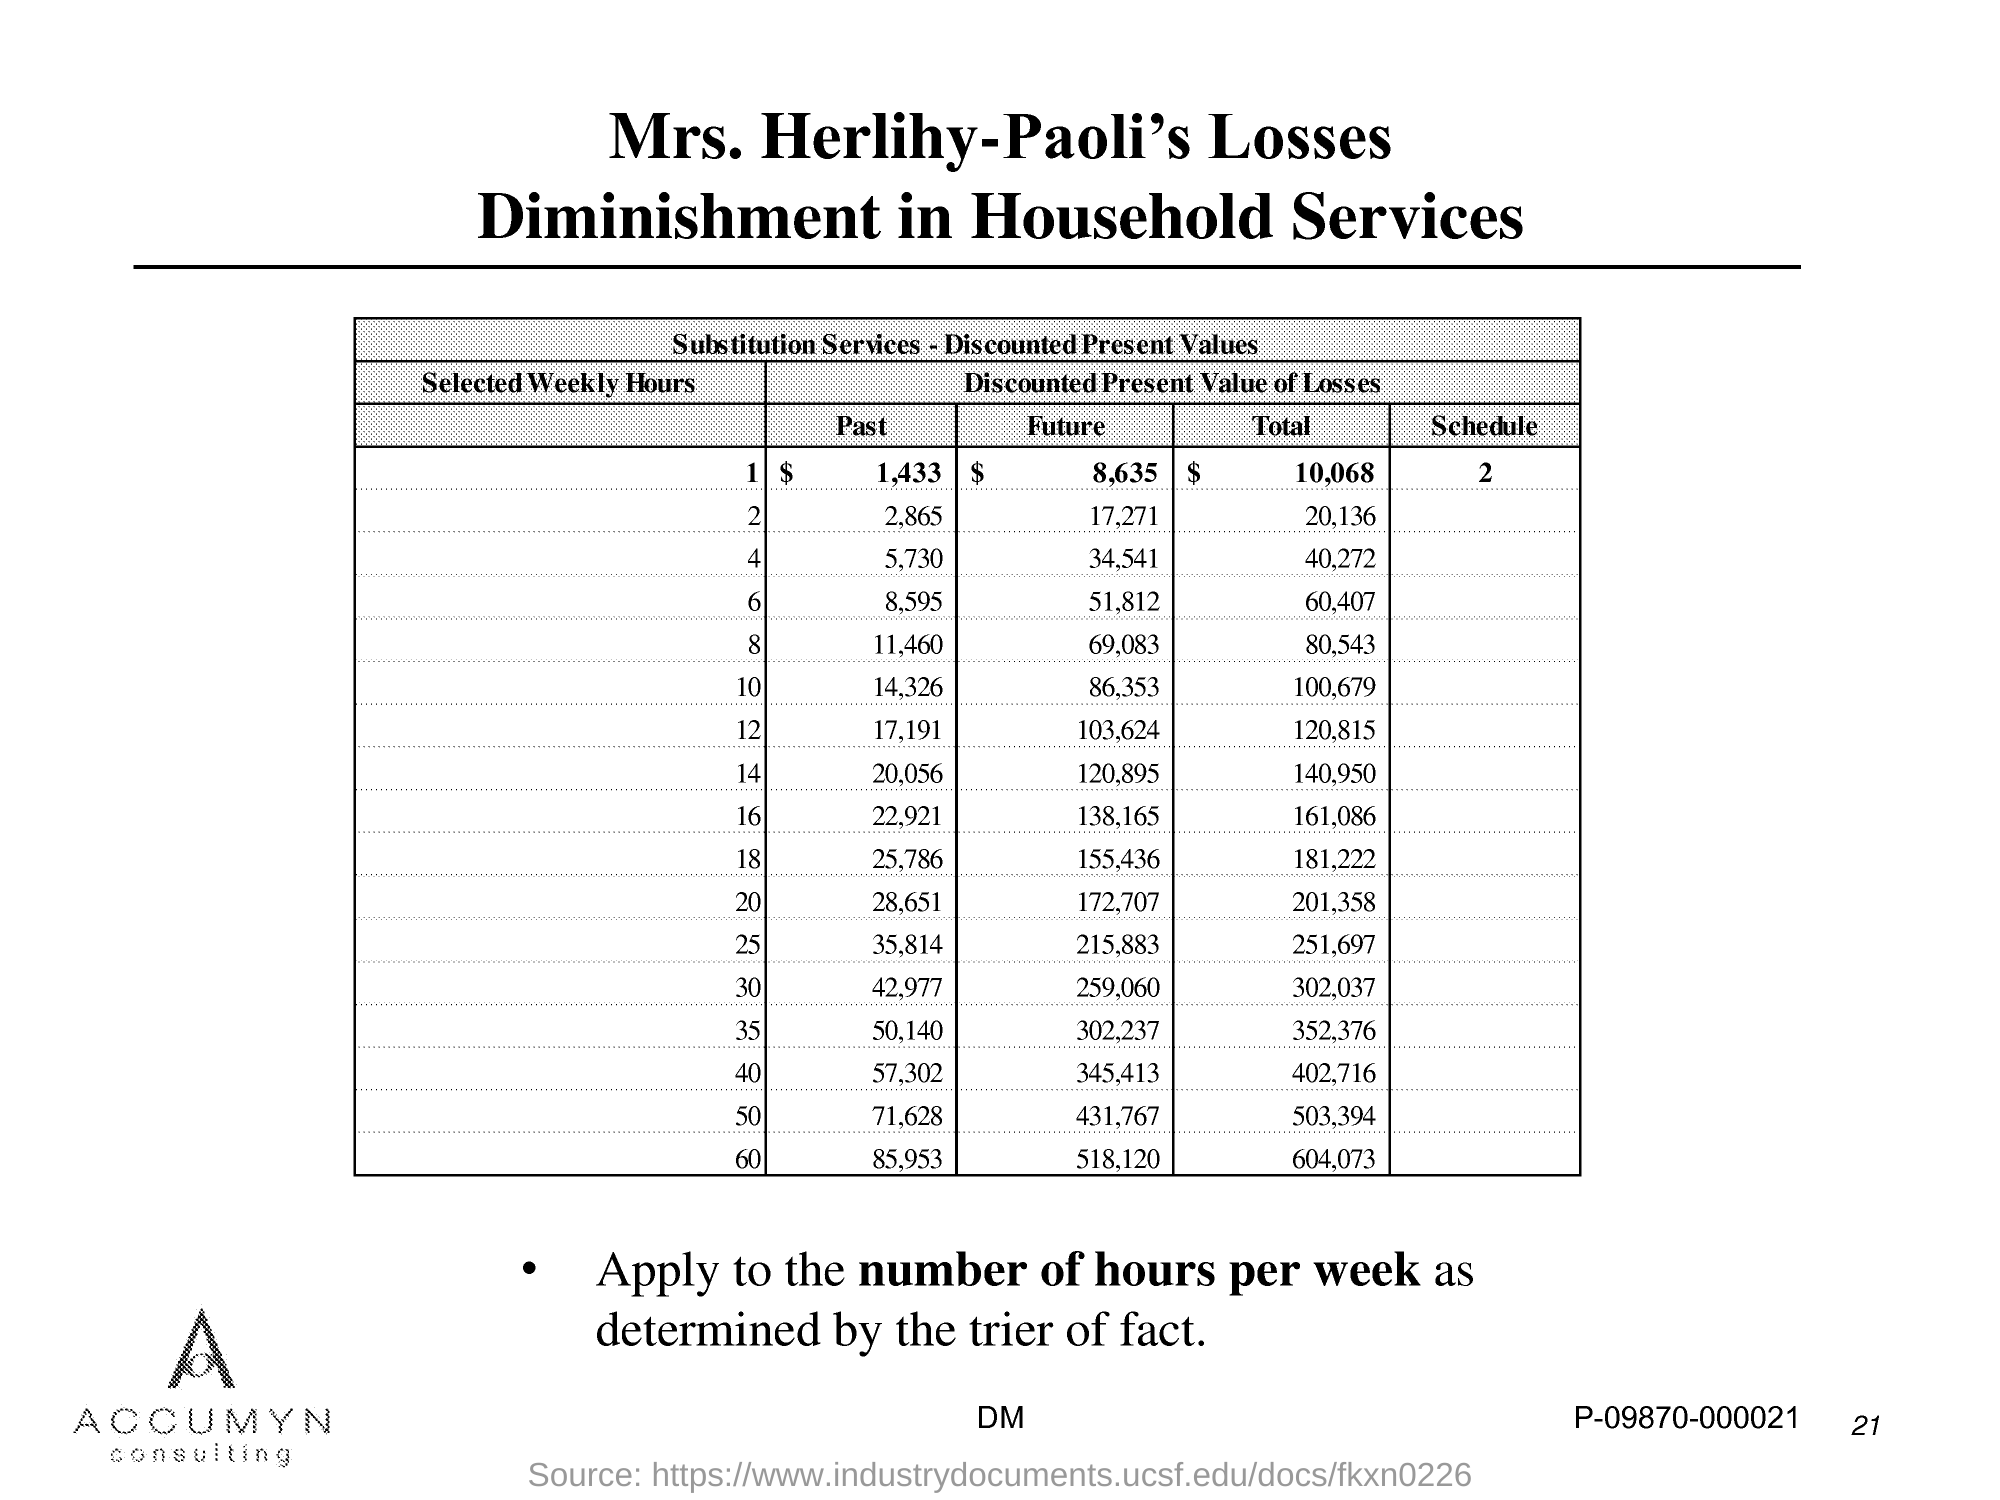What is the Page Number?
Offer a terse response. 21. What is the number of Schedules?
Provide a succinct answer. 2. What is the total amount for the selected weekly hour 1?
Provide a succinct answer. $ 10,068. What is the first title in the document?
Offer a very short reply. Mrs. Herlihy-Paoli's Losses. What is the second title in the document?
Make the answer very short. Diminishment in Household Services. 